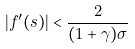Convert formula to latex. <formula><loc_0><loc_0><loc_500><loc_500>| f ^ { \prime } ( s ) | < \frac { 2 } { ( 1 + \gamma ) \sigma }</formula> 